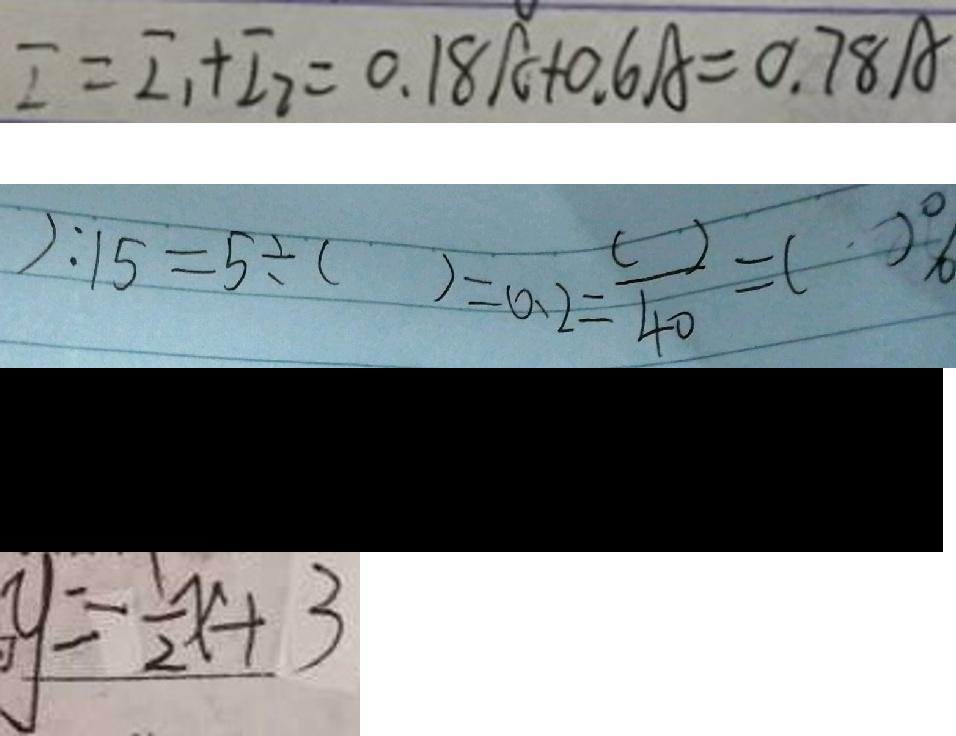<formula> <loc_0><loc_0><loc_500><loc_500>I = I _ { 1 } + I _ { 2 } = 0 . 1 8 A + 0 . 6 A = 0 . 7 8 A 
 ) : 1 5 = 5 \div ( ) = 0 . 2 = \frac { ( ) } { 4 0 } = ( ) \% 
 ( 2 x + 1 ) ^ { 2 } - ( 2 x - 5 ) 
 y = \frac { 1 } { 2 } x + 3</formula> 